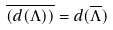<formula> <loc_0><loc_0><loc_500><loc_500>\overline { ( d ( \Lambda ) ) } = d ( \overline { \Lambda } )</formula> 